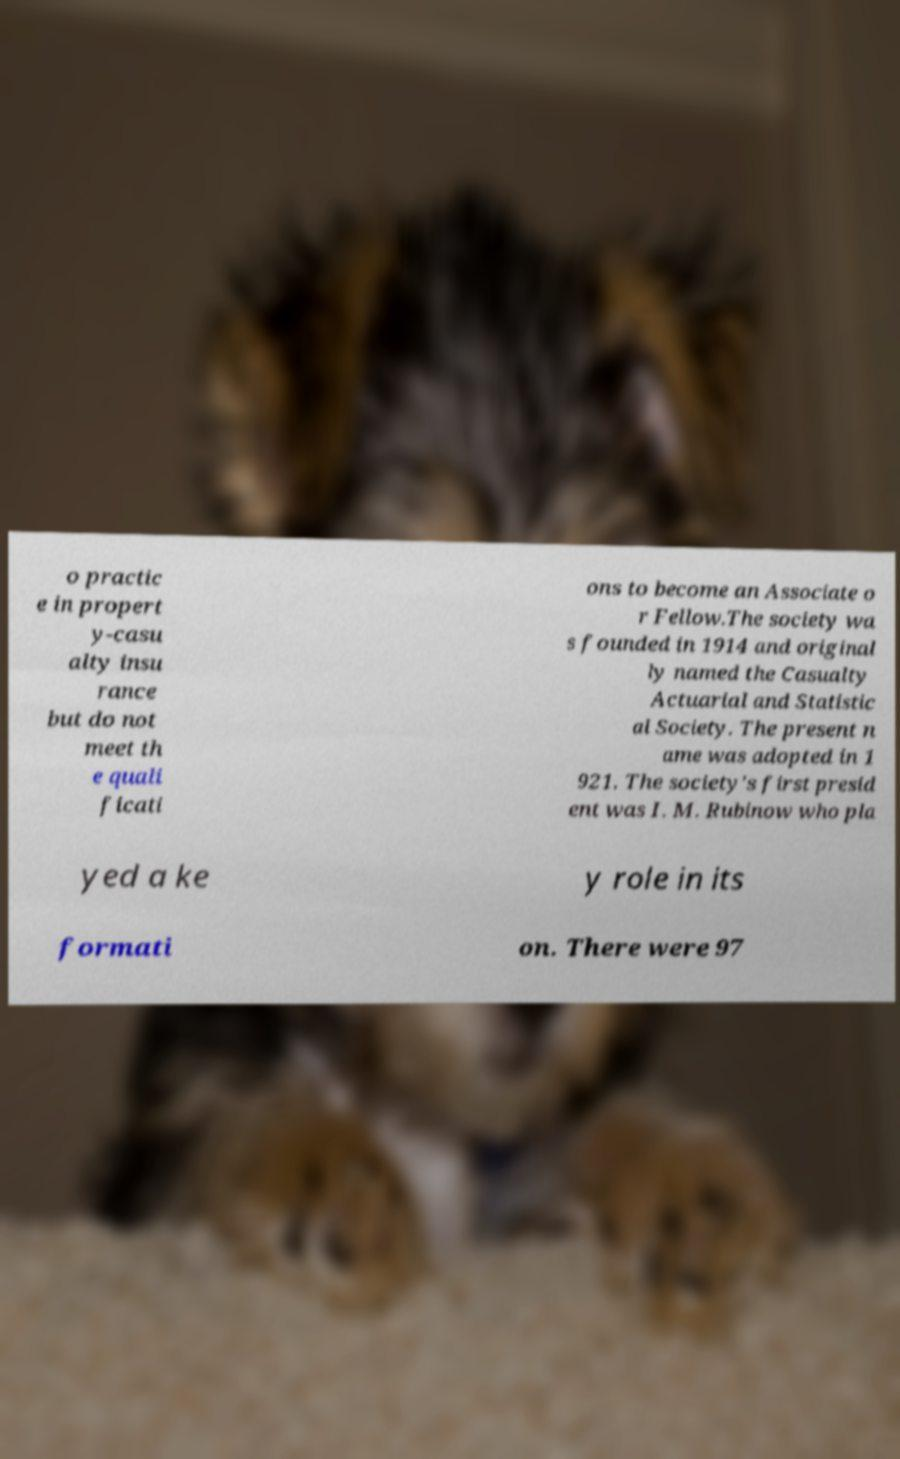Can you accurately transcribe the text from the provided image for me? o practic e in propert y-casu alty insu rance but do not meet th e quali ficati ons to become an Associate o r Fellow.The society wa s founded in 1914 and original ly named the Casualty Actuarial and Statistic al Society. The present n ame was adopted in 1 921. The society's first presid ent was I. M. Rubinow who pla yed a ke y role in its formati on. There were 97 